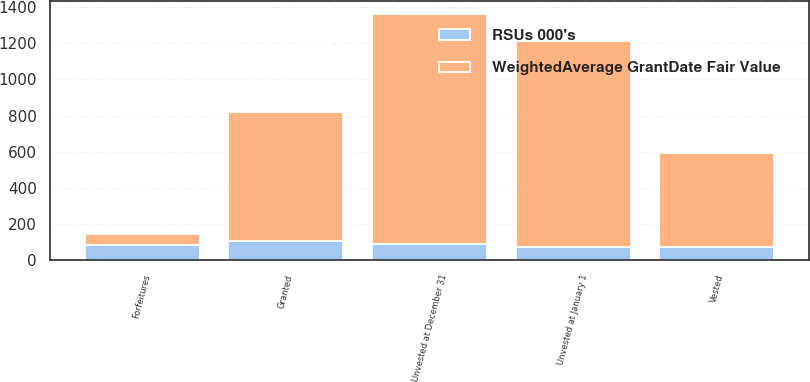<chart> <loc_0><loc_0><loc_500><loc_500><stacked_bar_chart><ecel><fcel>Unvested at January 1<fcel>Granted<fcel>Vested<fcel>Forfeitures<fcel>Unvested at December 31<nl><fcel>WeightedAverage GrantDate Fair Value<fcel>1137<fcel>717<fcel>518<fcel>64<fcel>1272<nl><fcel>RSUs 000's<fcel>73.44<fcel>104.74<fcel>73.68<fcel>82.83<fcel>90.5<nl></chart> 